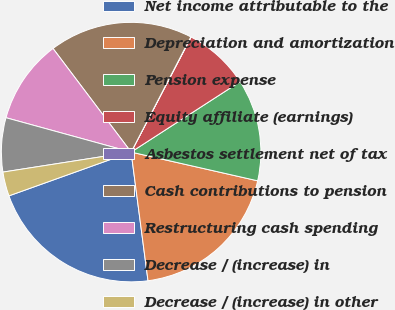<chart> <loc_0><loc_0><loc_500><loc_500><pie_chart><fcel>Net income attributable to the<fcel>Depreciation and amortization<fcel>Pension expense<fcel>Equity affiliate (earnings)<fcel>Asbestos settlement net of tax<fcel>Cash contributions to pension<fcel>Restructuring cash spending<fcel>Decrease / (increase) in<fcel>Decrease / (increase) in other<nl><fcel>21.6%<fcel>19.37%<fcel>12.68%<fcel>8.22%<fcel>0.04%<fcel>17.89%<fcel>10.45%<fcel>6.73%<fcel>3.01%<nl></chart> 